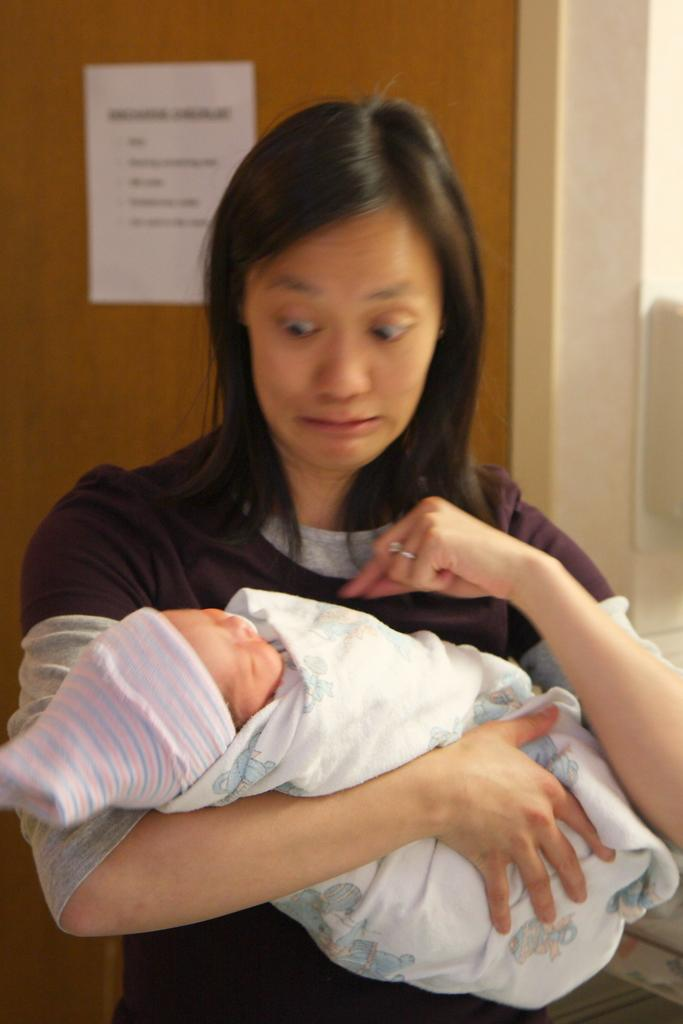What is the main subject of the image? There is a lady in the image. What is the lady doing in the image? The lady is standing and holding a baby in her hands. What can be seen behind the lady? There is a door behind the lady. What is written or displayed on the door? There is a paper with text on the door. Can you tell me how many alleys are visible in the image? There are no alleys present in the image. What type of sack is the lady carrying in the image? The lady is not carrying a sack in the image; she is holding a baby. 